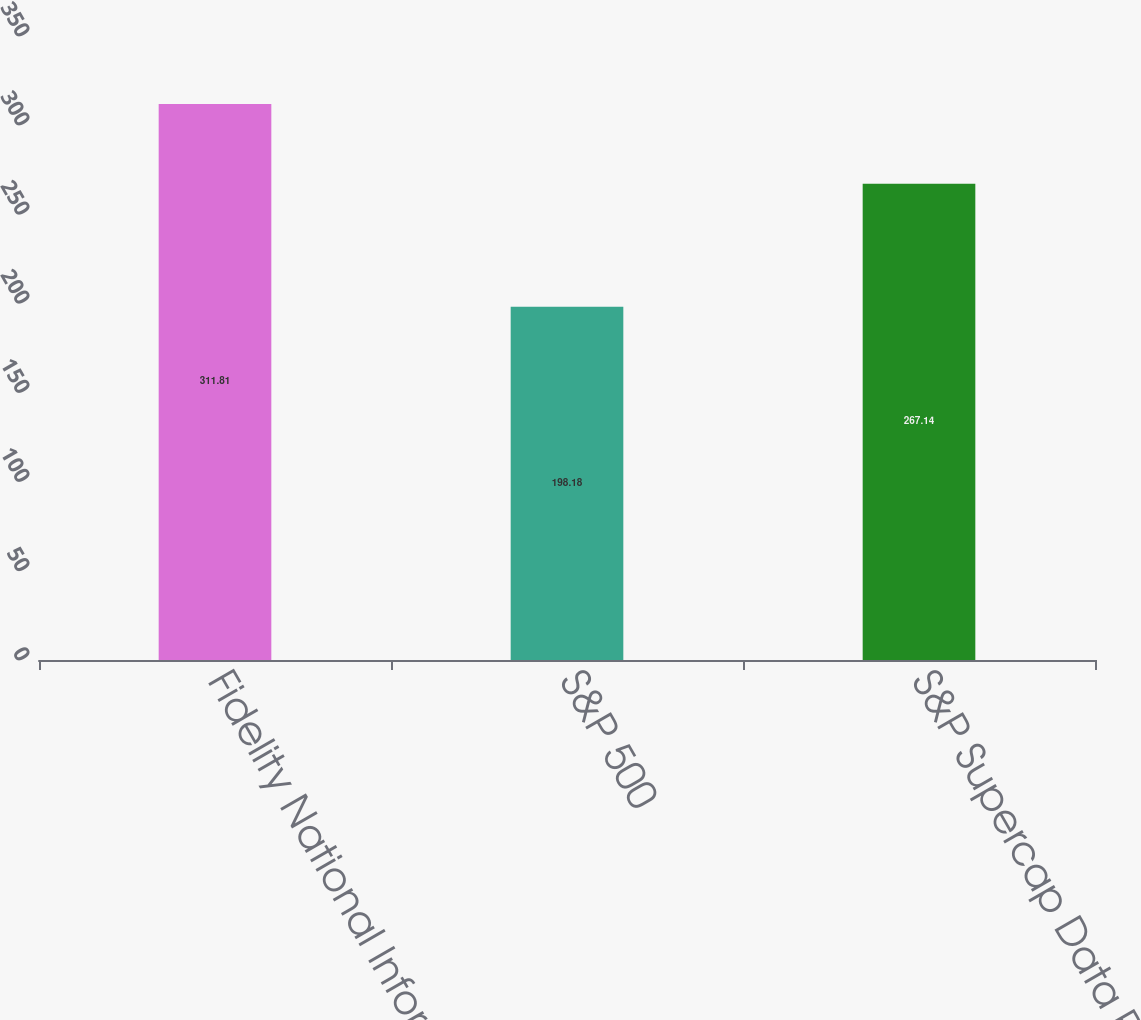Convert chart to OTSL. <chart><loc_0><loc_0><loc_500><loc_500><bar_chart><fcel>Fidelity National Information<fcel>S&P 500<fcel>S&P Supercap Data Processing &<nl><fcel>311.81<fcel>198.18<fcel>267.14<nl></chart> 